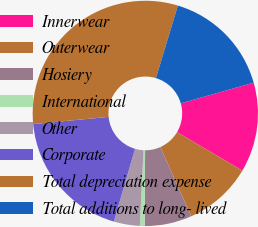Convert chart to OTSL. <chart><loc_0><loc_0><loc_500><loc_500><pie_chart><fcel>Innerwear<fcel>Outerwear<fcel>Hosiery<fcel>International<fcel>Other<fcel>Corporate<fcel>Total depreciation expense<fcel>Total additions to long- lived<nl><fcel>12.88%<fcel>9.83%<fcel>6.78%<fcel>0.68%<fcel>3.73%<fcel>18.98%<fcel>31.18%<fcel>15.93%<nl></chart> 